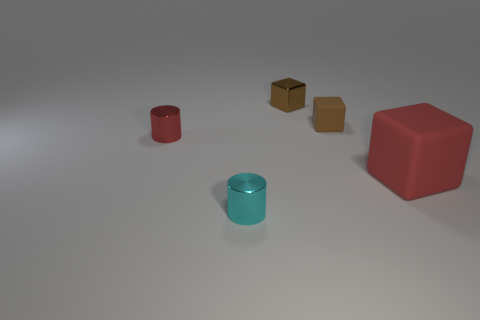Subtract all blocks. How many objects are left? 2 Add 4 small red things. How many small red things exist? 5 Add 2 red things. How many objects exist? 7 Subtract all cyan cylinders. How many cylinders are left? 1 Subtract all red blocks. How many blocks are left? 2 Subtract 0 gray blocks. How many objects are left? 5 Subtract 2 cubes. How many cubes are left? 1 Subtract all brown blocks. Subtract all blue spheres. How many blocks are left? 1 Subtract all yellow balls. How many gray cylinders are left? 0 Subtract all big cyan matte blocks. Subtract all shiny things. How many objects are left? 2 